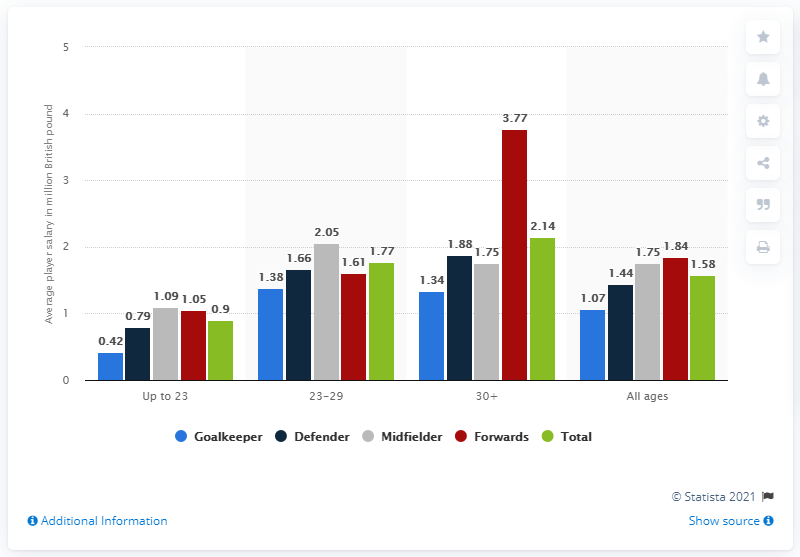List a handful of essential elements in this visual. The graph shows that the midfielder position has a high frequency of gray color, indicating a significant amount of activity in that role. The average of the first, second, and third highest value in the blue bar is 1.26. The average salary for a player aged 23-29 in the Bundesliga football league is approximately $0.9 million. The average yearly salary for under-23 players in basic pay is approximately $0.9 million. 